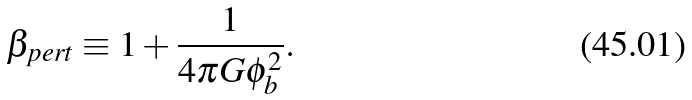<formula> <loc_0><loc_0><loc_500><loc_500>\beta _ { p e r t } \equiv 1 + \frac { 1 } { 4 \pi G \phi _ { b } ^ { 2 } } .</formula> 